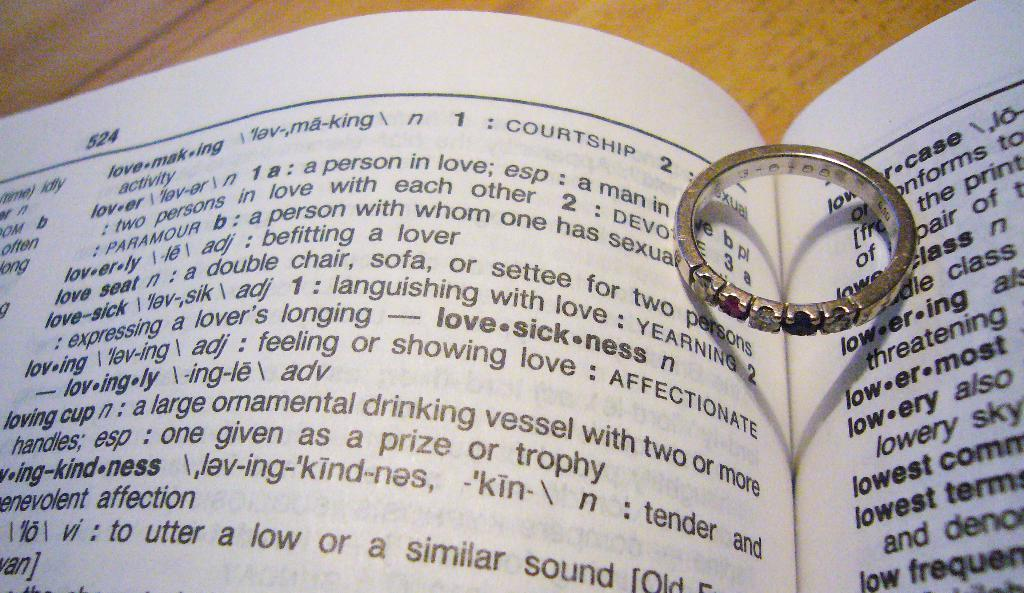What object can be seen in the image that is typically used for jewelry? There is a ring in the image. What type of object is present in the image that is typically used for reading or learning? There is a book with text in the image. What type of furniture is visible in the background of the image? There is a table in the background of the image. How many rabbits can be seen in the image? There are no rabbits present in the image. What type of art is displayed on the walls in the image? There is no mention of any art or walls in the image, so it cannot be determined if any art is displayed. 